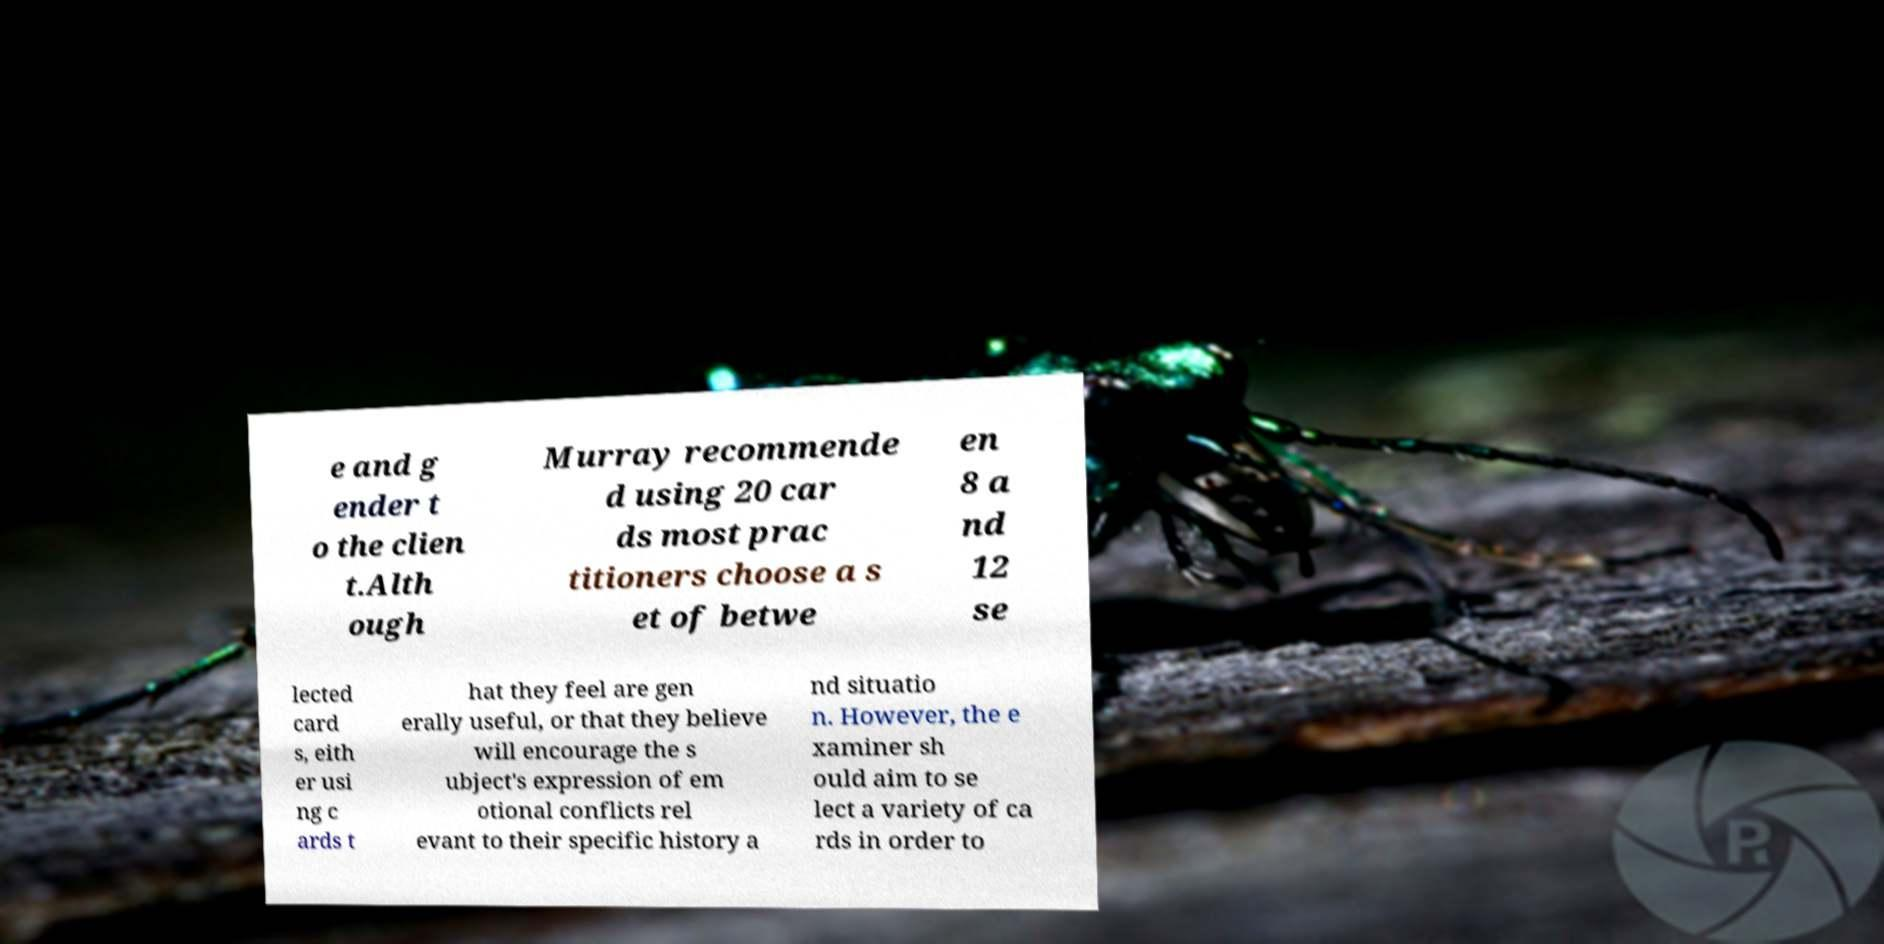Can you accurately transcribe the text from the provided image for me? e and g ender t o the clien t.Alth ough Murray recommende d using 20 car ds most prac titioners choose a s et of betwe en 8 a nd 12 se lected card s, eith er usi ng c ards t hat they feel are gen erally useful, or that they believe will encourage the s ubject's expression of em otional conflicts rel evant to their specific history a nd situatio n. However, the e xaminer sh ould aim to se lect a variety of ca rds in order to 